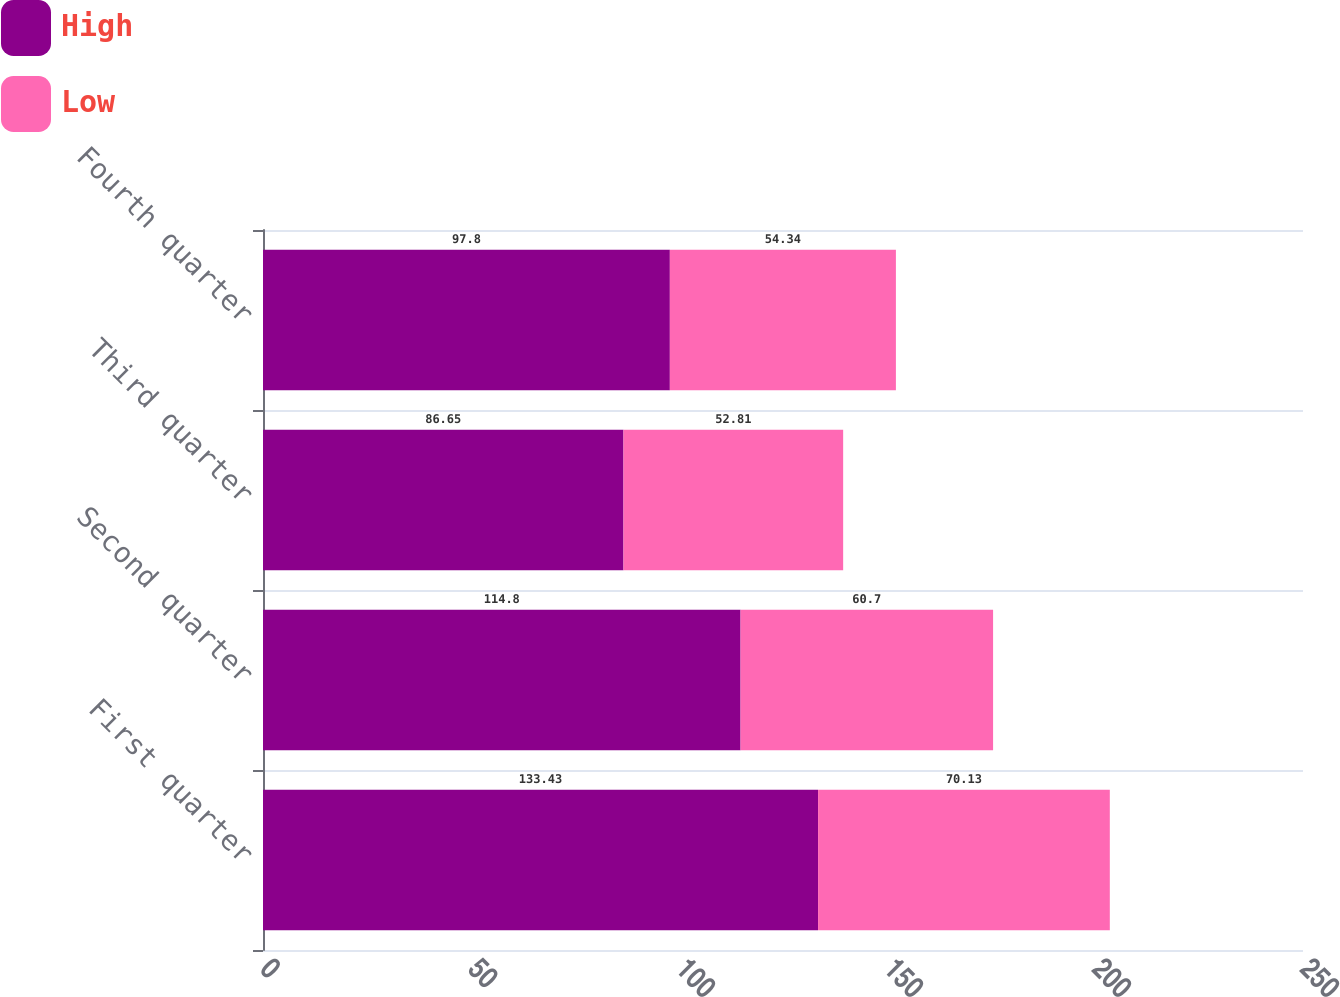<chart> <loc_0><loc_0><loc_500><loc_500><stacked_bar_chart><ecel><fcel>First quarter<fcel>Second quarter<fcel>Third quarter<fcel>Fourth quarter<nl><fcel>High<fcel>133.43<fcel>114.8<fcel>86.65<fcel>97.8<nl><fcel>Low<fcel>70.13<fcel>60.7<fcel>52.81<fcel>54.34<nl></chart> 